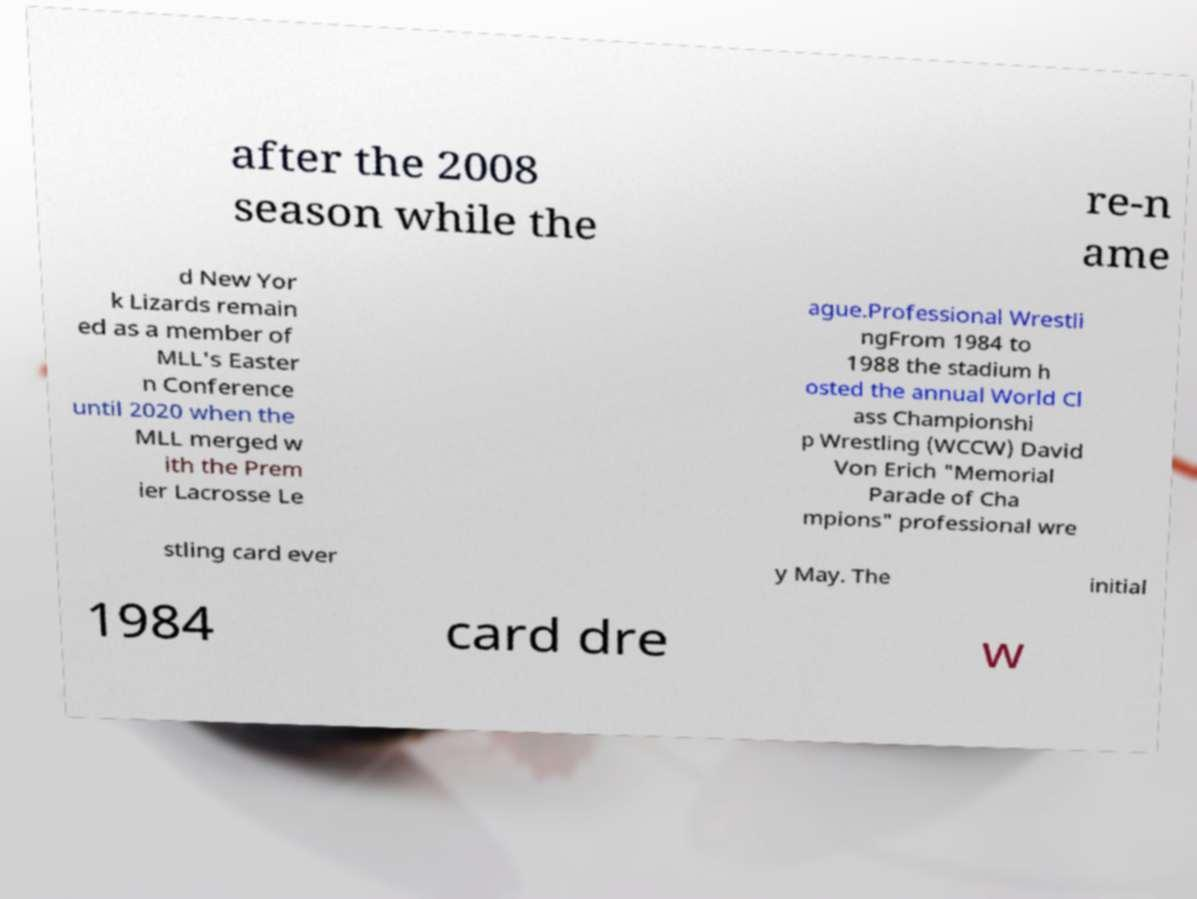What messages or text are displayed in this image? I need them in a readable, typed format. after the 2008 season while the re-n ame d New Yor k Lizards remain ed as a member of MLL's Easter n Conference until 2020 when the MLL merged w ith the Prem ier Lacrosse Le ague.Professional Wrestli ngFrom 1984 to 1988 the stadium h osted the annual World Cl ass Championshi p Wrestling (WCCW) David Von Erich "Memorial Parade of Cha mpions" professional wre stling card ever y May. The initial 1984 card dre w 